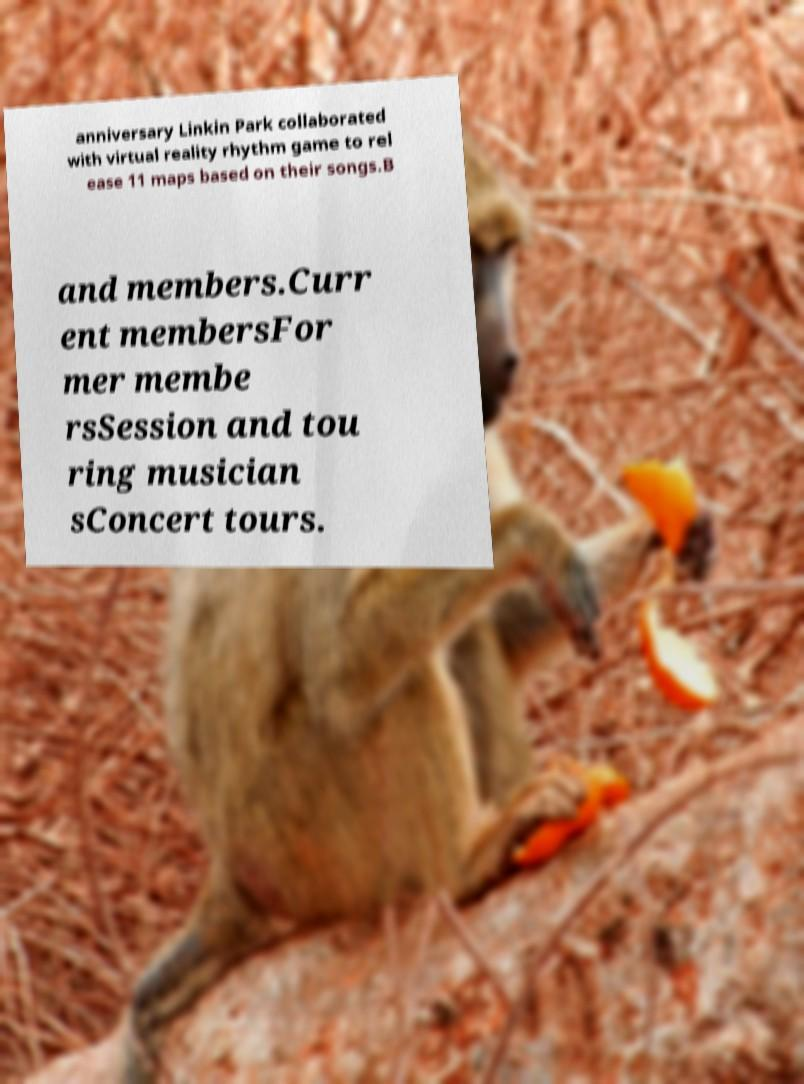What messages or text are displayed in this image? I need them in a readable, typed format. anniversary Linkin Park collaborated with virtual reality rhythm game to rel ease 11 maps based on their songs.B and members.Curr ent membersFor mer membe rsSession and tou ring musician sConcert tours. 